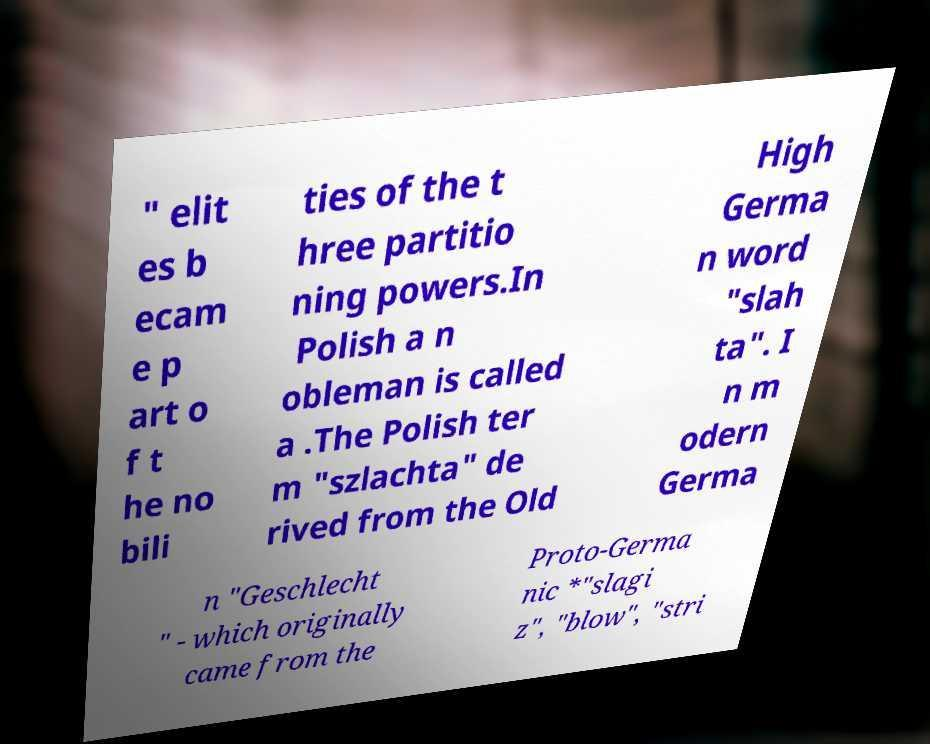Please identify and transcribe the text found in this image. " elit es b ecam e p art o f t he no bili ties of the t hree partitio ning powers.In Polish a n obleman is called a .The Polish ter m "szlachta" de rived from the Old High Germa n word "slah ta". I n m odern Germa n "Geschlecht " - which originally came from the Proto-Germa nic *"slagi z", "blow", "stri 